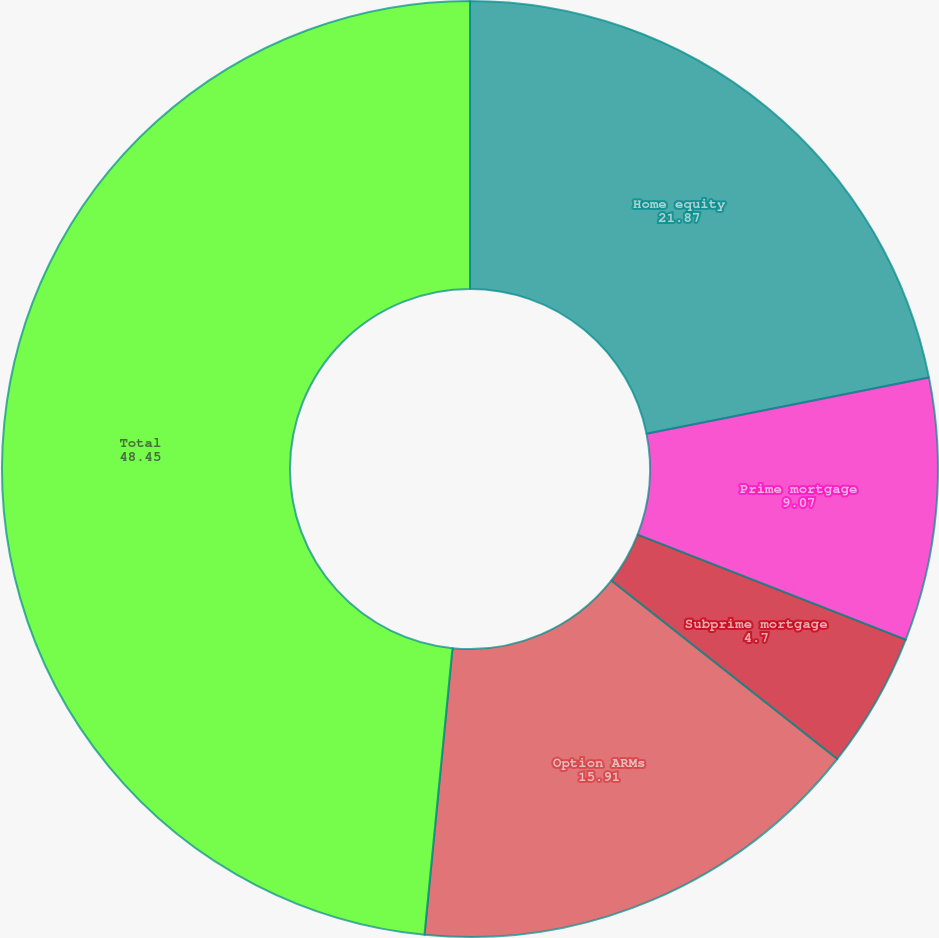<chart> <loc_0><loc_0><loc_500><loc_500><pie_chart><fcel>Home equity<fcel>Prime mortgage<fcel>Subprime mortgage<fcel>Option ARMs<fcel>Total<nl><fcel>21.87%<fcel>9.07%<fcel>4.7%<fcel>15.91%<fcel>48.45%<nl></chart> 